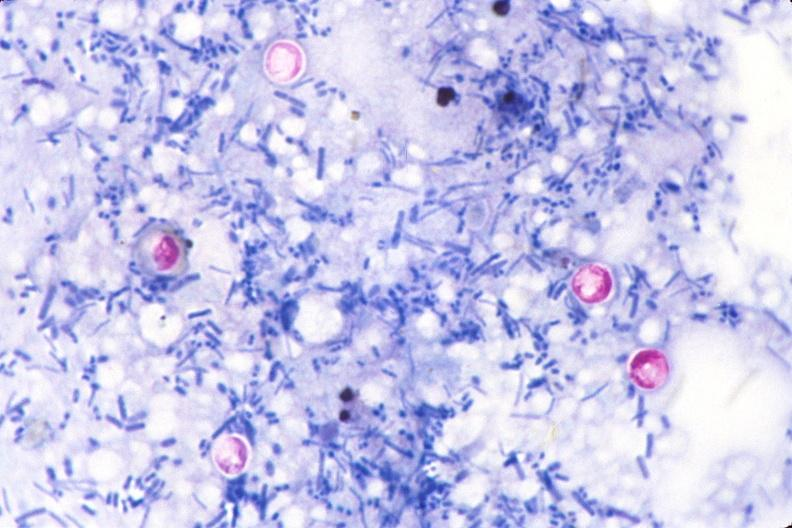what stain of feces?
Answer the question using a single word or phrase. Cryptosporidia, acid 